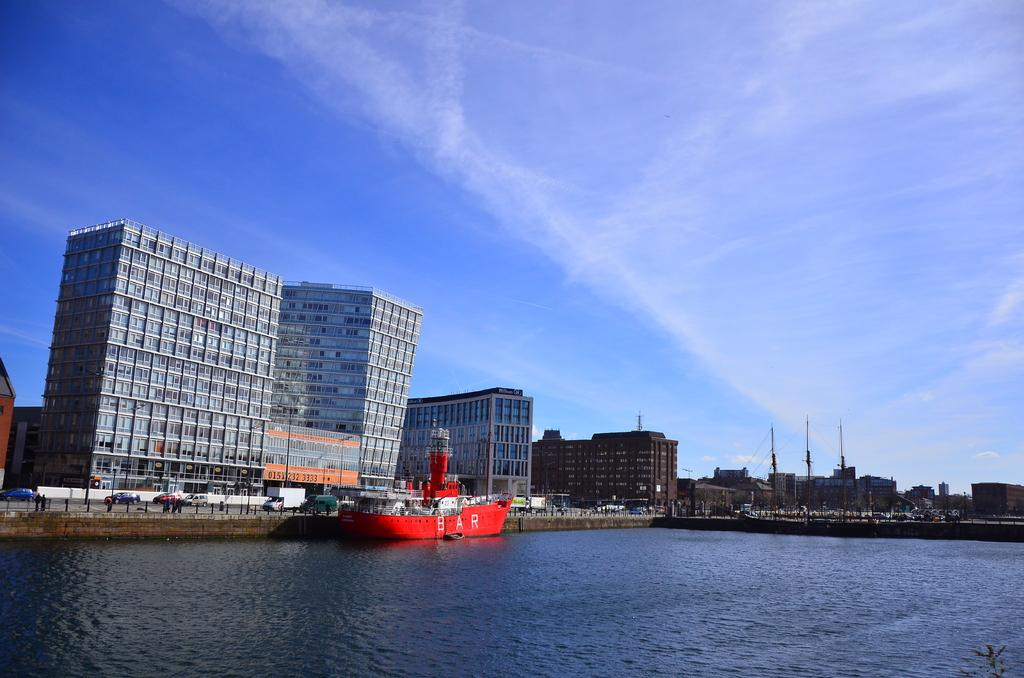What is the main subject of the image? The main subject of the image is a boat on water. What else can be seen in the image besides the boat? Vehicles are visible on the road beside the water, and there are buildings and electrical poles present in the image. What is visible in the background of the image? The sky is visible in the background of the image. How many clovers are growing near the boat in the image? There are no clovers visible in the image; it features a boat on water, vehicles on the road, buildings, electrical poles, and the sky. Are the brothers in the image running towards the boat? There is no mention of brothers or running in the image; it only shows a boat on water, vehicles on road, buildings, electrical poles, and the sky. 